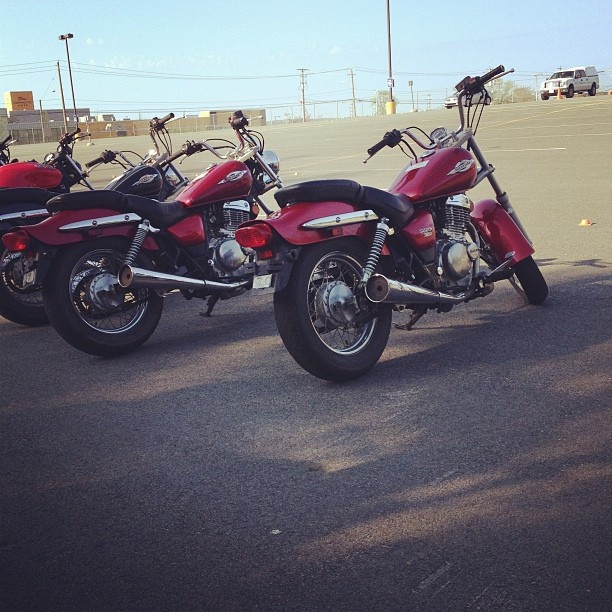Describe the objects in this image and their specific colors. I can see motorcycle in lightblue, black, gray, and darkgray tones, motorcycle in lightblue, black, gray, and purple tones, motorcycle in lightblue, black, darkgray, gray, and maroon tones, motorcycle in lightblue, black, maroon, gray, and brown tones, and truck in lightblue, darkgray, white, gray, and black tones in this image. 